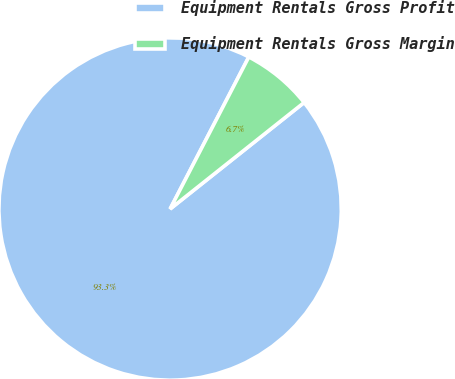Convert chart. <chart><loc_0><loc_0><loc_500><loc_500><pie_chart><fcel>Equipment Rentals Gross Profit<fcel>Equipment Rentals Gross Margin<nl><fcel>93.29%<fcel>6.71%<nl></chart> 